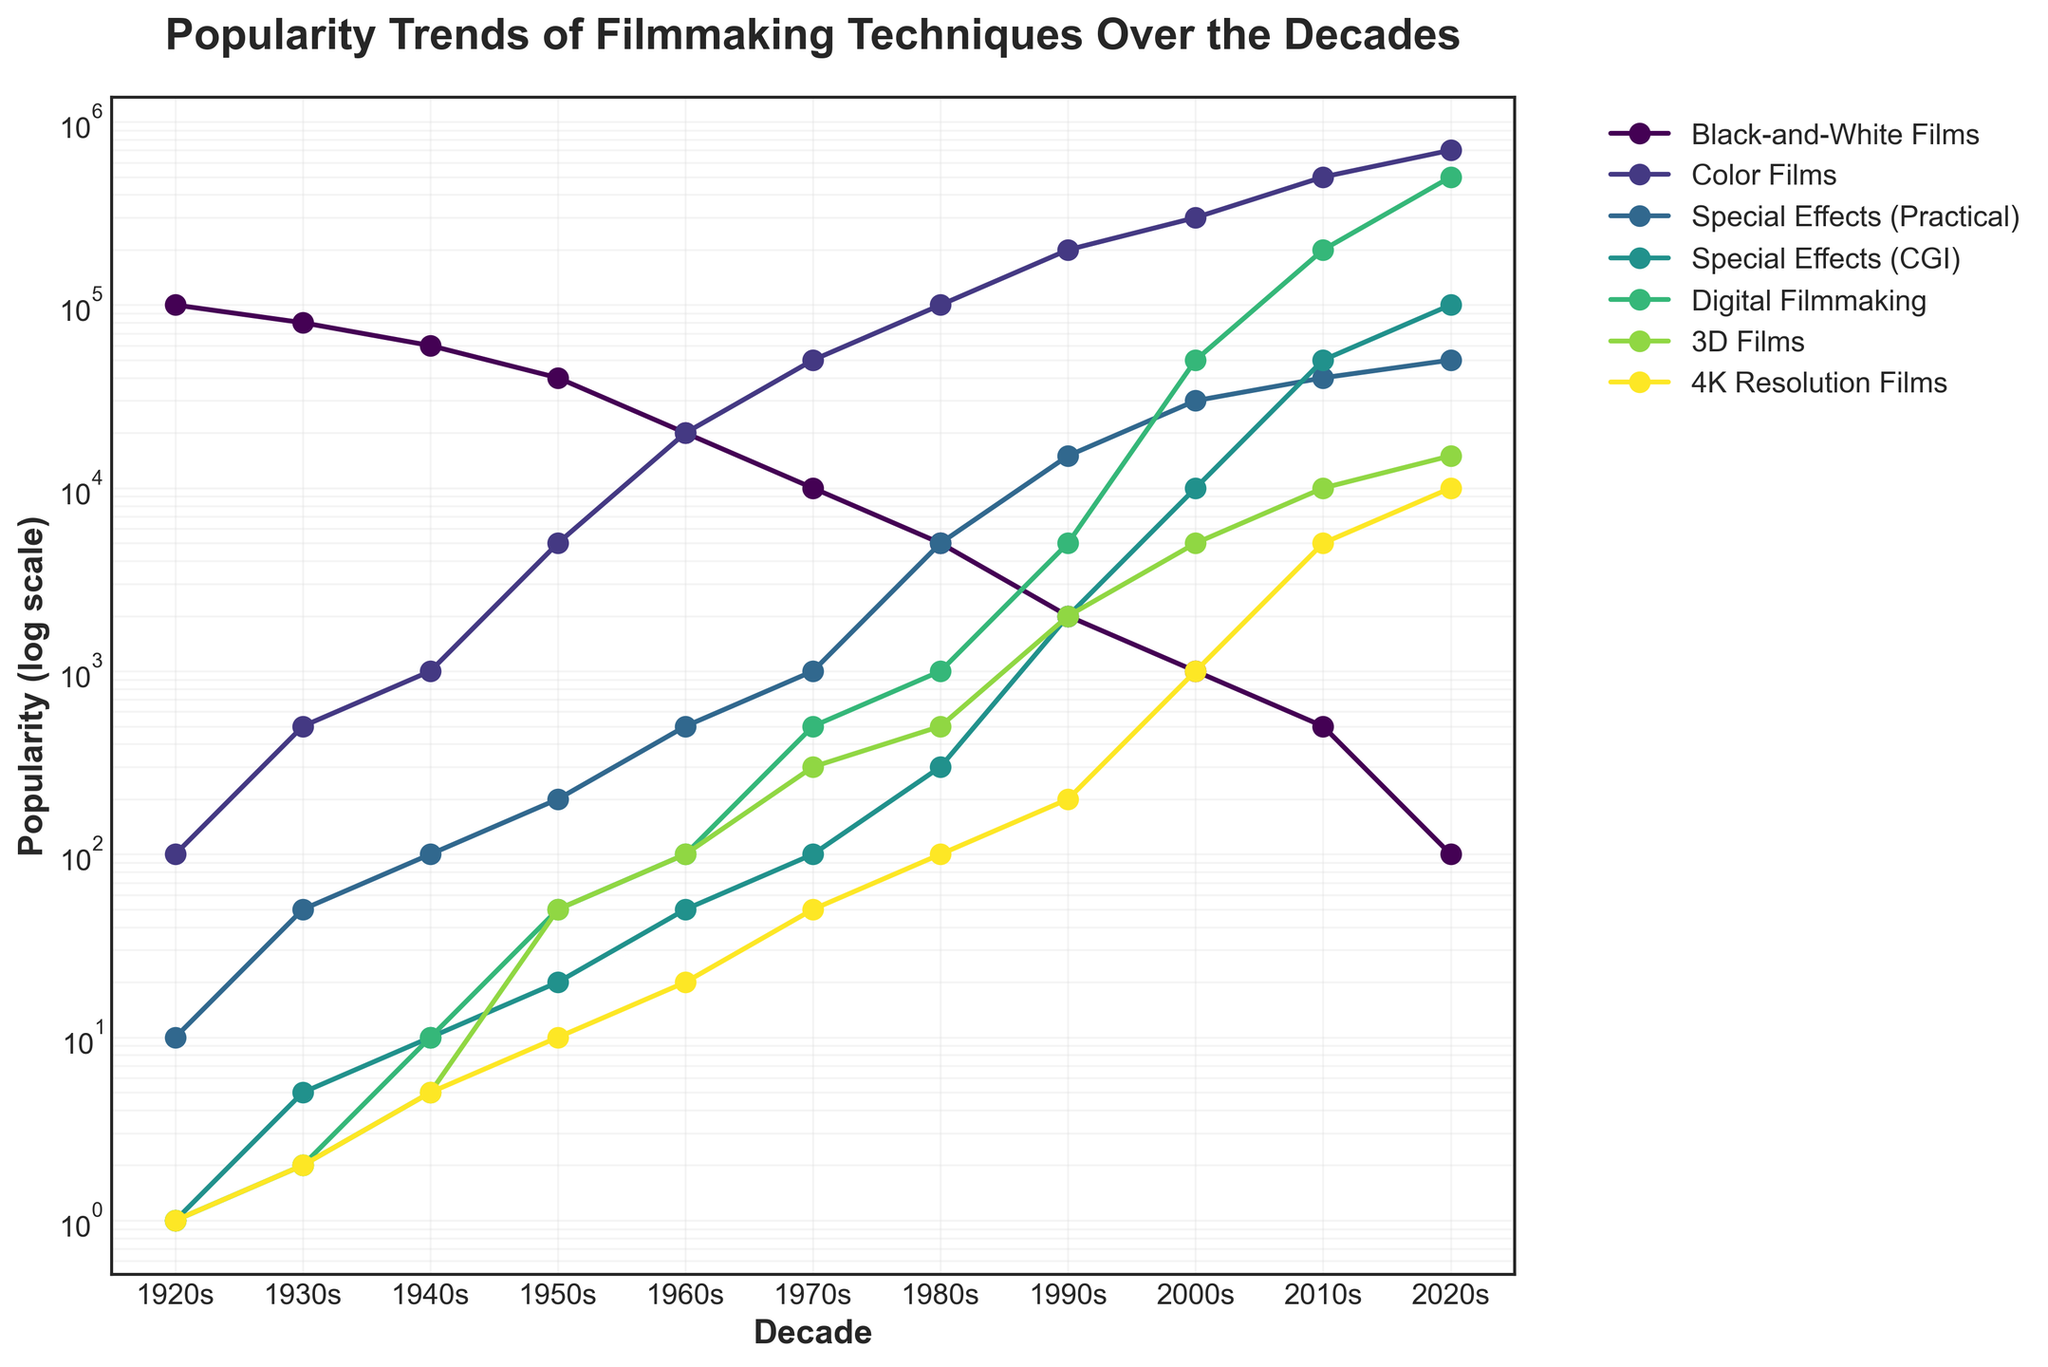what is the title of the figure? The title is located at the top of the figure. It is written in a larger and bold font to catch the viewer's attention and give a clear indication of what the figure represents. The title here reads "Popularity Trends of Filmmaking Techniques Over the Decades."
Answer: Popularity Trends of Filmmaking Techniques Over the Decades how does the popularity of black-and-white films change from the 1920s to the 2020s? Observing the plot, you can see that the trend line for black-and-white films starts at a high value in the 1920s but steadily declines over the decades until it reaches a very low value by the 2020s.
Answer: It declines steadily which decade saw the most significant rise in color films' popularity? By examining the trend lines, you can see that the line representing color films shows the most dramatic increase between the 1940s and 1950s. This sharp rise indicates that the popularity of color films surged significantly during that period.
Answer: 1950s in which decade does CGI surpass practical special effects in popularity? Looking at the trend lines for both "Special Effects (Practical)" and "Special Effects (CGI)", you find that CGI's line surpasses that of practical effects around the 2000s.
Answer: 2000s what's the relationship between digital filmmaking and 3D films in the 2010s? To find this, you look at the values for both digital filmmaking and 3D films in the 2010s. Digital filmmaking shows a considerably higher value compared to 3D films. Thus, digital filmmaking was much more popular than 3D films in the 2010s.
Answer: Digital filmmaking is more popular which filmmaking technique or technology shows the largest growth from the 2000s to the 2020s? To answer this, compare the values for each technique in the 2000s and 2020s. The largest discrepancy is seen in digital filmmaking, which grows from 50,000 in the 2000s to 500,000 in the 2020s.
Answer: Digital filmmaking in the 2020s, how does the popularity of 3D films compare with 4K resolution films? By locating the respective points for the 2020s on the plot, 3D films have a value of 15,000 while 4K resolution films have a value of 10,000. Thus, 3D films are more popular than 4K resolution films in the 2020s.
Answer: 3D films are more popular is there any filmmaking technique or technology that shows a consistent increase in popularity throughout all decades? Review each trend line to see if any maintain a consistent upward trajectory. The lines for digital filmmaking and CGI show a consistent increase without declines from their points of inception.
Answer: Digital filmmaking and CGI in which decade did the popularity of special effects (practical) peak? Observe the peak point of the "Special Effects (Practical)" line on the plot. Its highest value occurs in the 2020s.
Answer: 2020s 